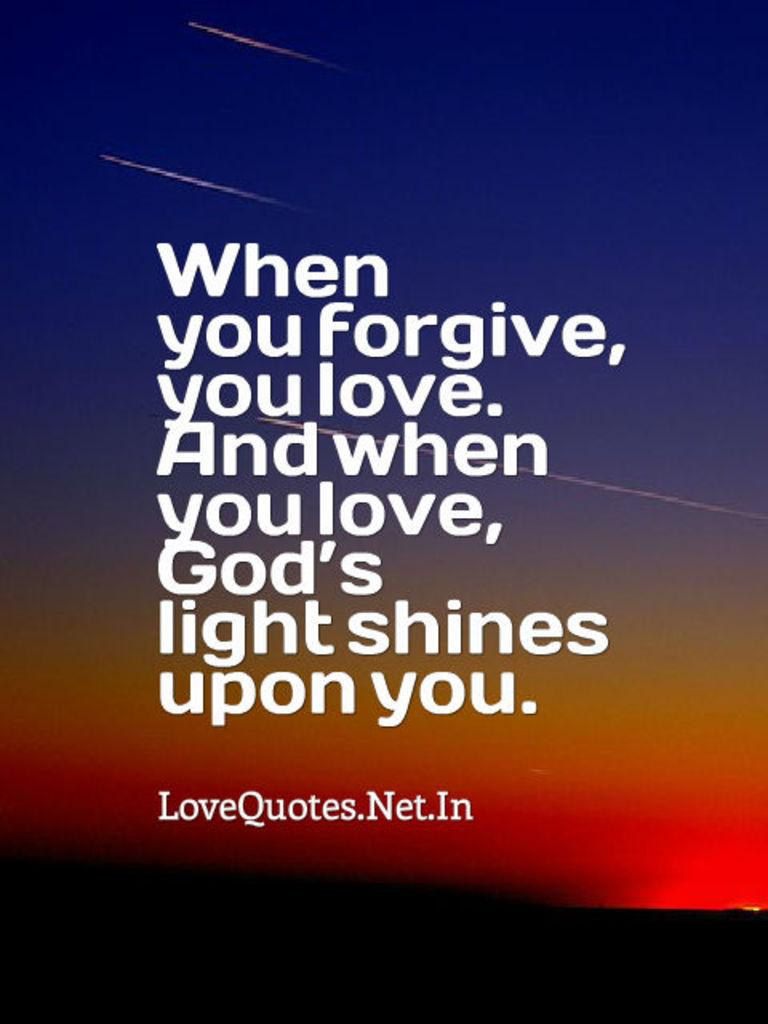<image>
Offer a succinct explanation of the picture presented. A sunset with the quote when you forgive, you love and when you love, God's light shines upon you. 